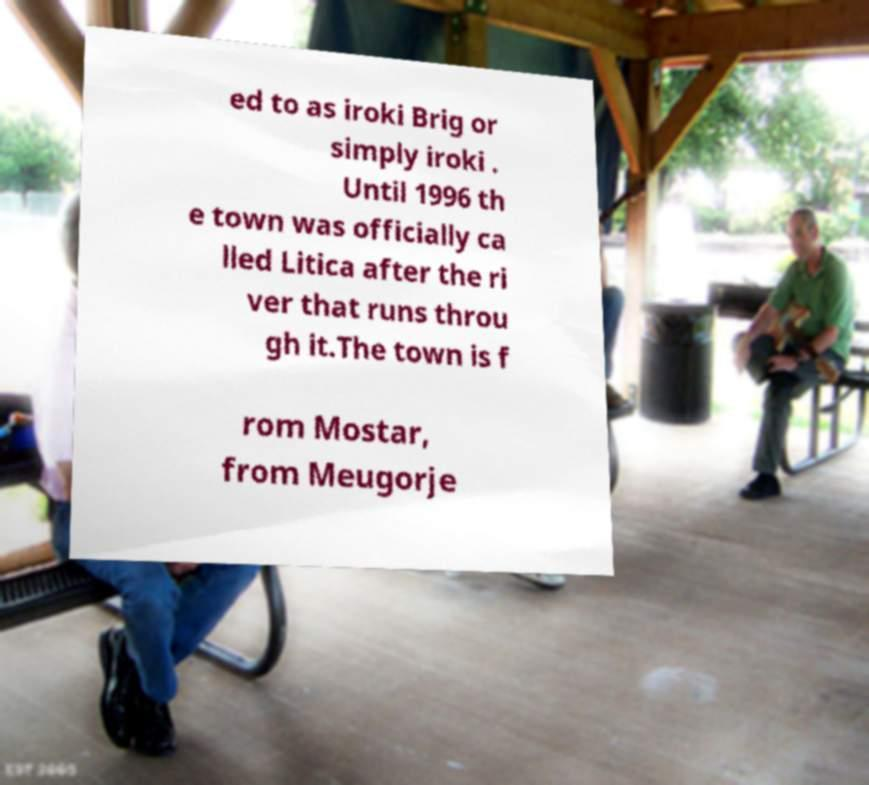Please identify and transcribe the text found in this image. ed to as iroki Brig or simply iroki . Until 1996 th e town was officially ca lled Litica after the ri ver that runs throu gh it.The town is f rom Mostar, from Meugorje 